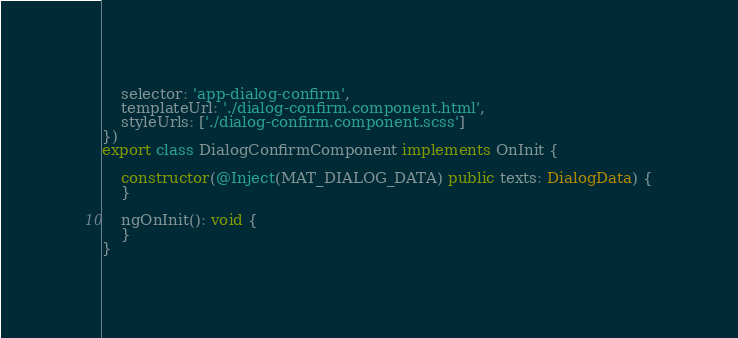<code> <loc_0><loc_0><loc_500><loc_500><_TypeScript_>    selector: 'app-dialog-confirm',
    templateUrl: './dialog-confirm.component.html',
    styleUrls: ['./dialog-confirm.component.scss']
})
export class DialogConfirmComponent implements OnInit {

    constructor(@Inject(MAT_DIALOG_DATA) public texts: DialogData) {
    }

    ngOnInit(): void {
    }
}
</code> 